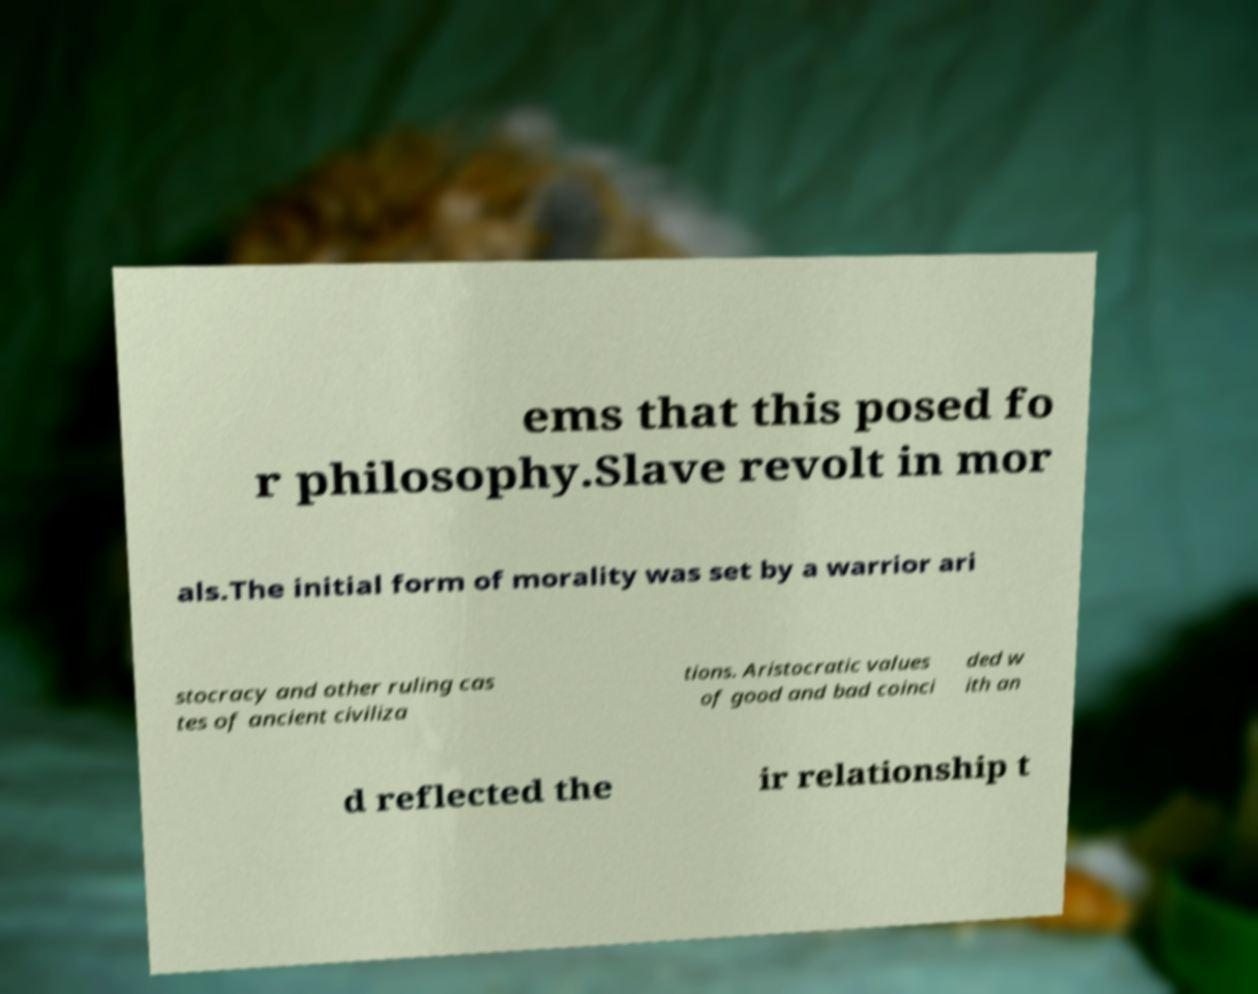Could you extract and type out the text from this image? ems that this posed fo r philosophy.Slave revolt in mor als.The initial form of morality was set by a warrior ari stocracy and other ruling cas tes of ancient civiliza tions. Aristocratic values of good and bad coinci ded w ith an d reflected the ir relationship t 